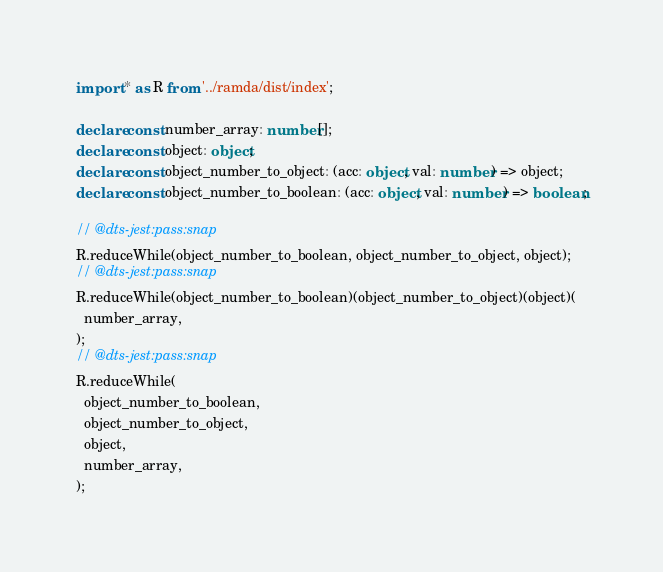<code> <loc_0><loc_0><loc_500><loc_500><_TypeScript_>import * as R from '../ramda/dist/index';

declare const number_array: number[];
declare const object: object;
declare const object_number_to_object: (acc: object, val: number) => object;
declare const object_number_to_boolean: (acc: object, val: number) => boolean;

// @dts-jest:pass:snap
R.reduceWhile(object_number_to_boolean, object_number_to_object, object);
// @dts-jest:pass:snap
R.reduceWhile(object_number_to_boolean)(object_number_to_object)(object)(
  number_array,
);
// @dts-jest:pass:snap
R.reduceWhile(
  object_number_to_boolean,
  object_number_to_object,
  object,
  number_array,
);
</code> 